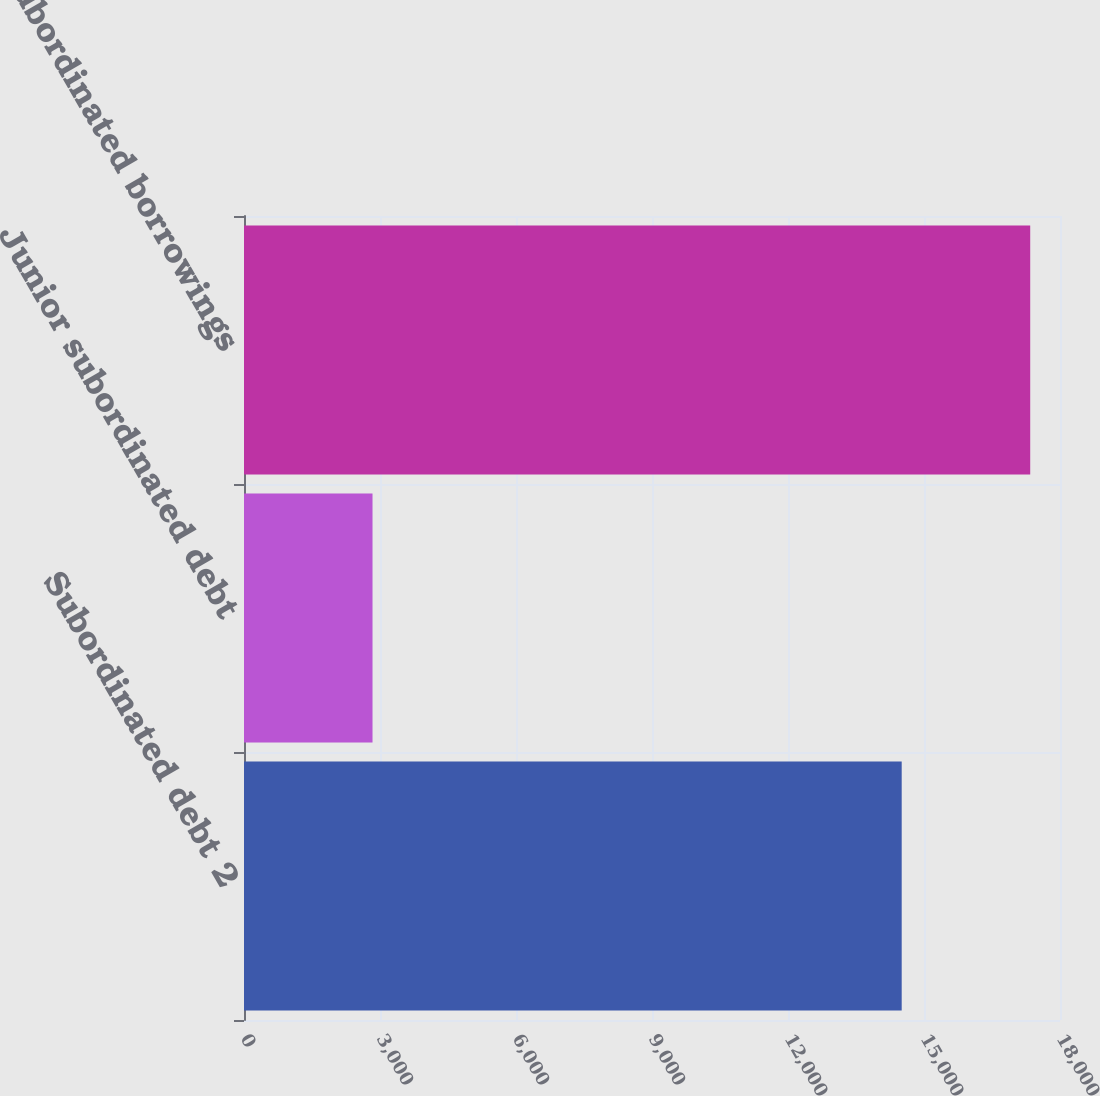Convert chart to OTSL. <chart><loc_0><loc_0><loc_500><loc_500><bar_chart><fcel>Subordinated debt 2<fcel>Junior subordinated debt<fcel>Total subordinated borrowings<nl><fcel>14508<fcel>2835<fcel>17343<nl></chart> 